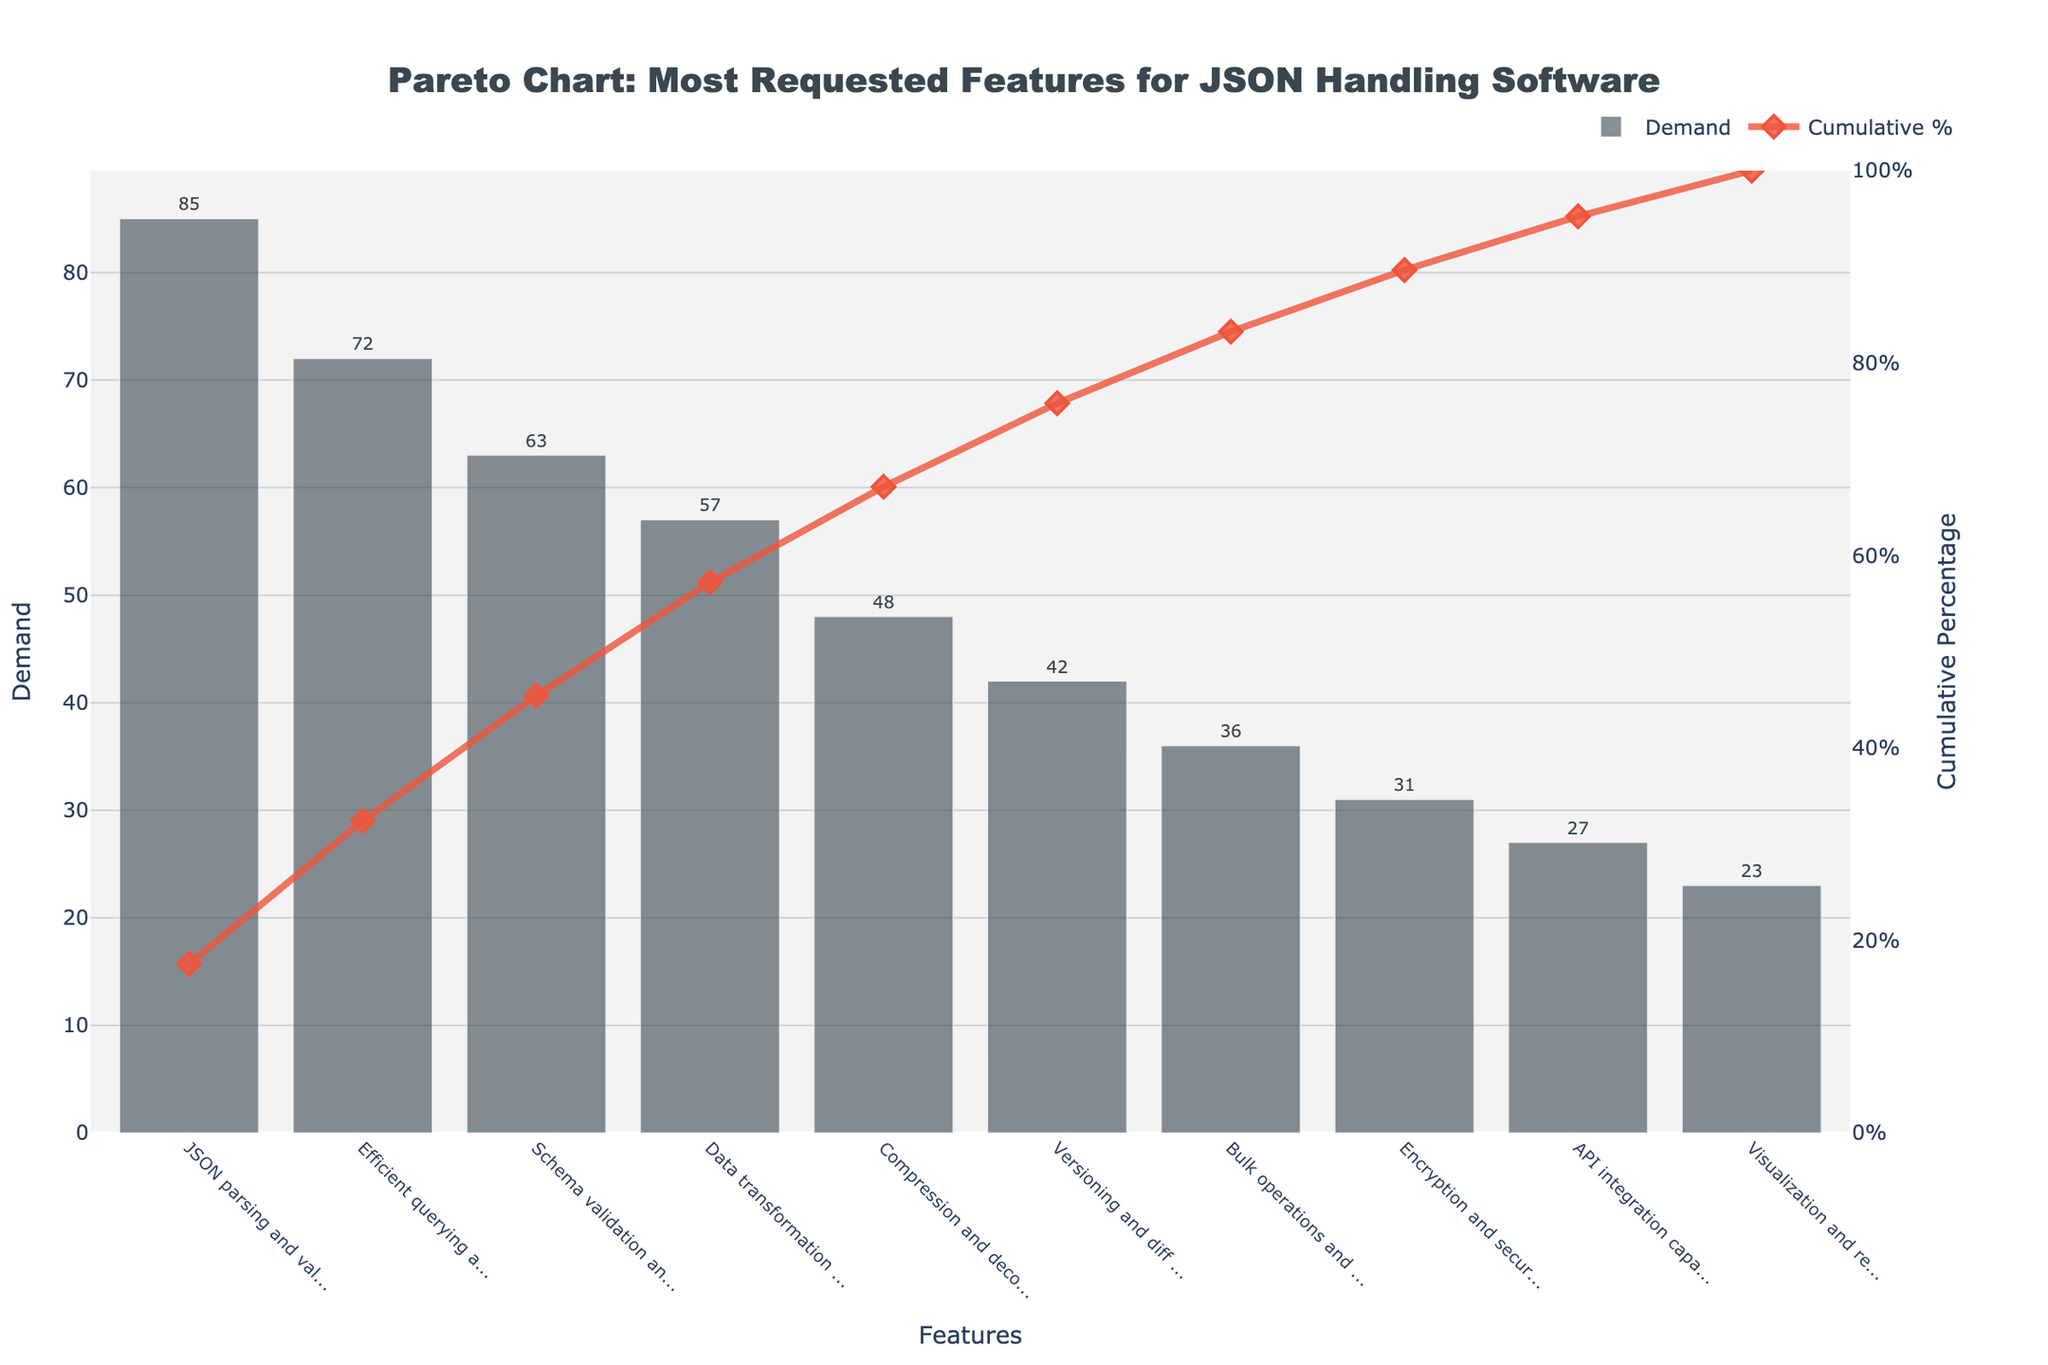Which feature has the highest demand? The bar with the highest value corresponds to the "JSON parsing and validation" feature, as indicated by its significantly tall bar.
Answer: JSON parsing and validation What is the cumulative percentage for "Schema validation and enforcement"? Locate the "Schema validation and enforcement" feature on the x-axis and refer to the line graph above it, which shows the cumulative percentage at that point.
Answer: 67.5% What percentage of total demand does "Efficient querying and filtering" represent? Determine the demand for "Efficient querying and filtering" (72) and divide it by the total demand (484), then multiply by 100.
Answer: 14.9% Which features represent the top 80% of the cumulative demand? Identify the point on the line chart where the cumulative percentage reaches 80% and list all features to the left of this point.
Answer: JSON parsing and validation, Efficient querying and filtering, Schema validation and enforcement, Data transformation and mapping How does the demand for "Visualization and reporting tools" compare to "Bulk operations and batch processing"? Compare the heights of the bars for both features. The bar for "Bulk operations and batch processing" is taller than that of "Visualization and reporting tools."
Answer: Bulk operations and batch processing is higher What is the total demand for the top three features combined? Add the demand values for the top three features: 85 (JSON parsing and validation) + 72 (Efficient querying and filtering) + 63 (Schema validation and enforcement).
Answer: 220 What feature has the lowest demand and what is its cumulative percentage? The last bar (shortest) represents the "Visualization and reporting tools" with the lowest demand. Refer to the line chart above this feature for the cumulative percentage.
Answer: Visualization and reporting tools, 100% Which feature's demand exceeds 50 but is less than 60? Identify the feature whose bar height falls within this range. "Data transformation and mapping" (57) meets this criterion.
Answer: Data transformation and mapping How many features have a demand of 40 or more? Count the number of bars that reach a height of 40 or more units.
Answer: Six What is the interval between the cumulative percentages at the highest and lowest demanded features? Subtract the cumulative percentage of the lowest demand feature from that of the highest demand feature: 100% - 17.6%.
Answer: 82.4% 